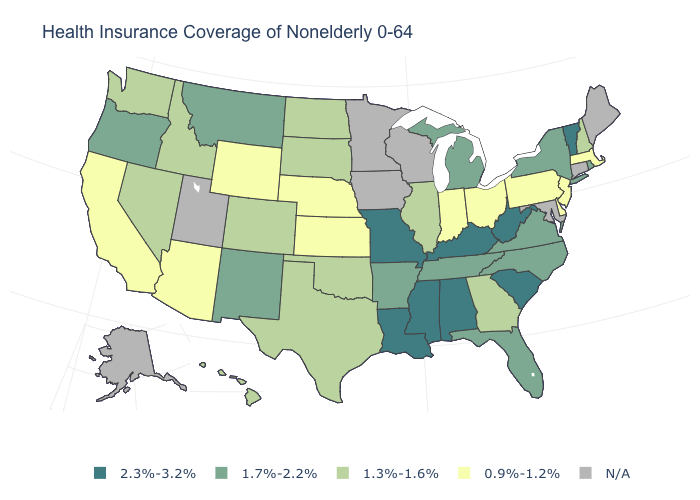What is the value of California?
Keep it brief. 0.9%-1.2%. What is the value of Massachusetts?
Quick response, please. 0.9%-1.2%. Does the map have missing data?
Concise answer only. Yes. Which states hav the highest value in the Northeast?
Concise answer only. Vermont. What is the value of Hawaii?
Keep it brief. 1.3%-1.6%. What is the value of Louisiana?
Keep it brief. 2.3%-3.2%. Name the states that have a value in the range N/A?
Be succinct. Alaska, Connecticut, Iowa, Maine, Maryland, Minnesota, Utah, Wisconsin. What is the value of Pennsylvania?
Short answer required. 0.9%-1.2%. What is the value of Nebraska?
Concise answer only. 0.9%-1.2%. What is the value of Maryland?
Give a very brief answer. N/A. Name the states that have a value in the range 1.3%-1.6%?
Be succinct. Colorado, Georgia, Hawaii, Idaho, Illinois, Nevada, New Hampshire, North Dakota, Oklahoma, South Dakota, Texas, Washington. Which states have the lowest value in the West?
Give a very brief answer. Arizona, California, Wyoming. Does the map have missing data?
Answer briefly. Yes. Which states have the lowest value in the USA?
Quick response, please. Arizona, California, Delaware, Indiana, Kansas, Massachusetts, Nebraska, New Jersey, Ohio, Pennsylvania, Wyoming. 